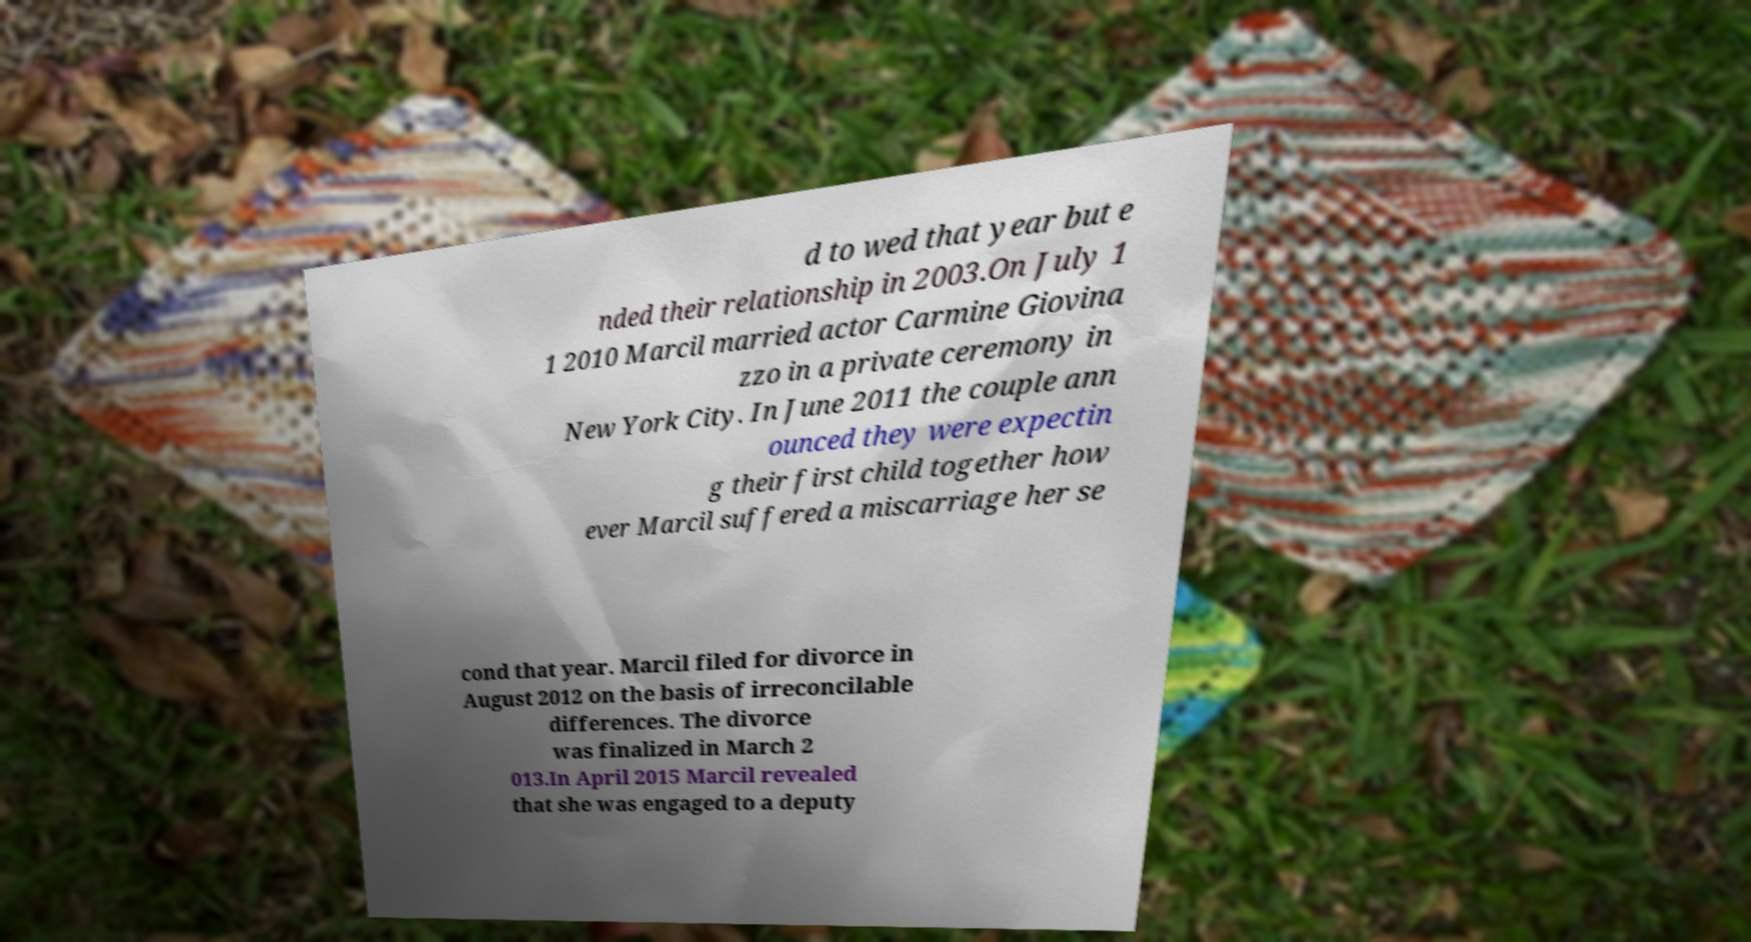Could you assist in decoding the text presented in this image and type it out clearly? d to wed that year but e nded their relationship in 2003.On July 1 1 2010 Marcil married actor Carmine Giovina zzo in a private ceremony in New York City. In June 2011 the couple ann ounced they were expectin g their first child together how ever Marcil suffered a miscarriage her se cond that year. Marcil filed for divorce in August 2012 on the basis of irreconcilable differences. The divorce was finalized in March 2 013.In April 2015 Marcil revealed that she was engaged to a deputy 